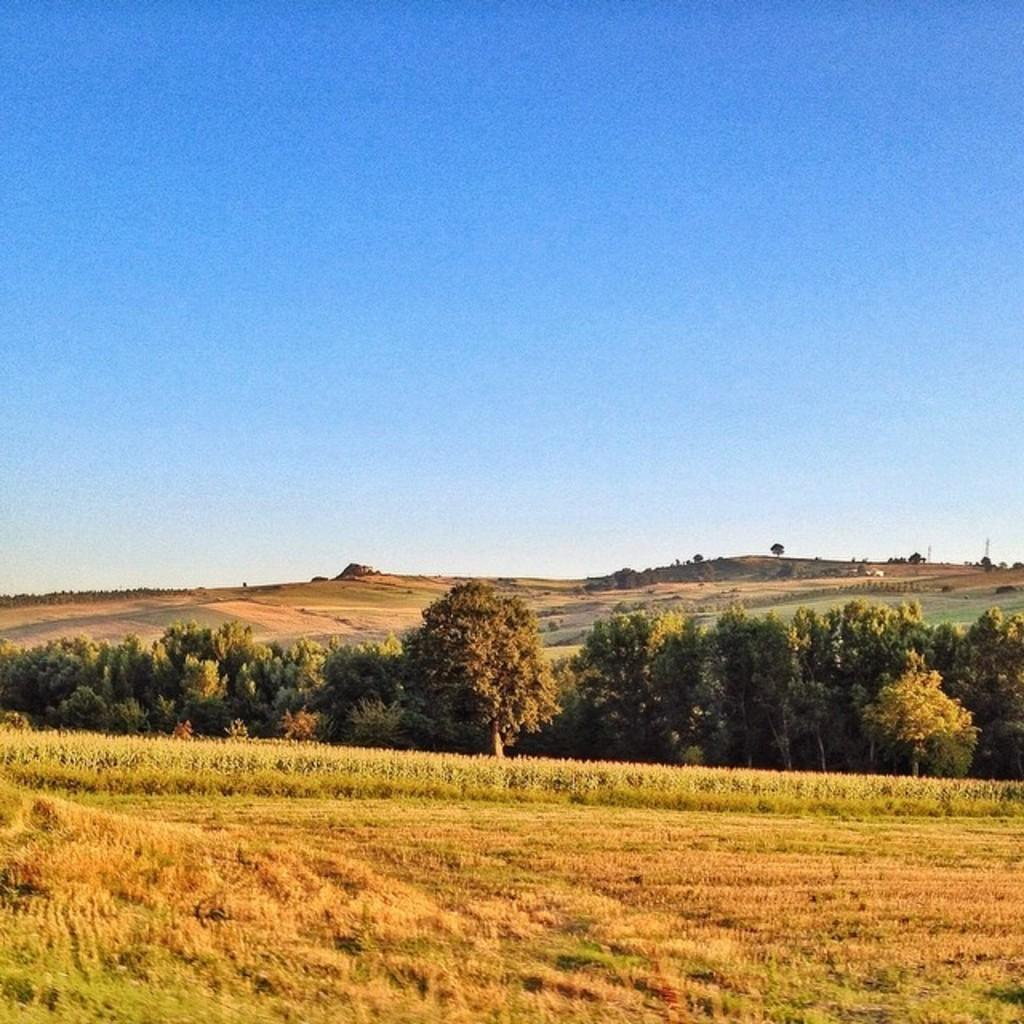Where was the image taken? The image was taken outside. What type of vegetation can be seen at the bottom of the image? There is grass and plants at the bottom of the image. What can be seen in the center of the image? There are trees in the center of the image. What is visible in the background of the image? There are hills visible in the background of the image. What is visible at the top of the image? The sky is visible at the top of the image. What flavor of shoe is visible in the image? There is no shoe present in the image, and therefore no flavor can be determined. 